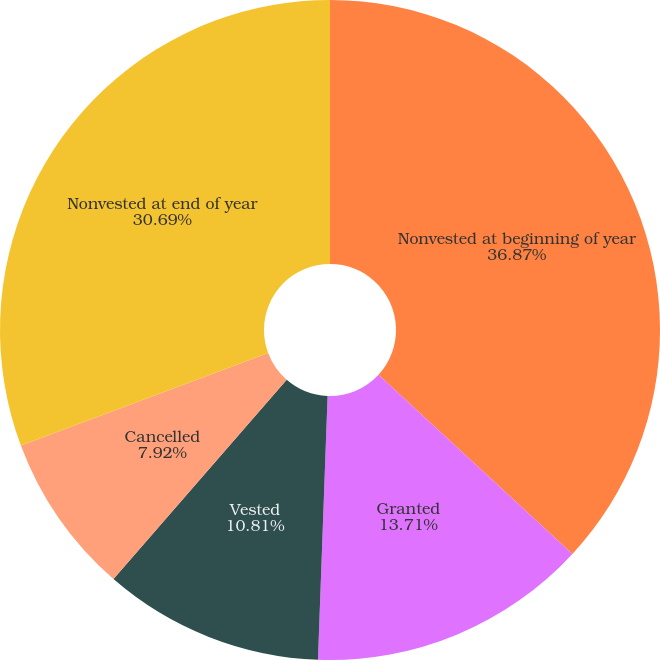Convert chart to OTSL. <chart><loc_0><loc_0><loc_500><loc_500><pie_chart><fcel>Nonvested at beginning of year<fcel>Granted<fcel>Vested<fcel>Cancelled<fcel>Nonvested at end of year<nl><fcel>36.87%<fcel>13.71%<fcel>10.81%<fcel>7.92%<fcel>30.69%<nl></chart> 